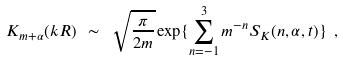Convert formula to latex. <formula><loc_0><loc_0><loc_500><loc_500>K _ { m + \alpha } ( k R ) \ \sim \ \sqrt { \frac { \pi } { 2 m } } \exp \{ \sum _ { n = - 1 } ^ { 3 } m ^ { - n } S _ { K } ( n , \alpha , t ) \} \ ,</formula> 